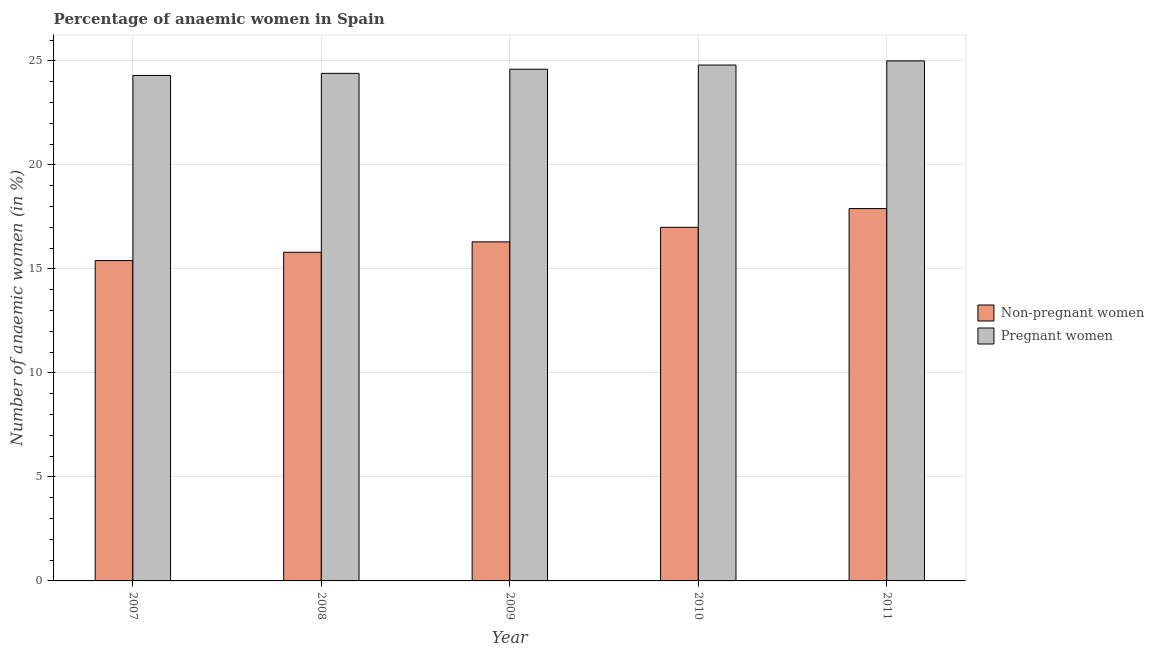How many different coloured bars are there?
Provide a short and direct response. 2. Are the number of bars per tick equal to the number of legend labels?
Ensure brevity in your answer.  Yes. Are the number of bars on each tick of the X-axis equal?
Keep it short and to the point. Yes. How many bars are there on the 2nd tick from the left?
Your answer should be very brief. 2. In how many cases, is the number of bars for a given year not equal to the number of legend labels?
Keep it short and to the point. 0. What is the percentage of non-pregnant anaemic women in 2008?
Make the answer very short. 15.8. Across all years, what is the maximum percentage of pregnant anaemic women?
Give a very brief answer. 25. In which year was the percentage of non-pregnant anaemic women minimum?
Your answer should be compact. 2007. What is the total percentage of pregnant anaemic women in the graph?
Provide a short and direct response. 123.1. What is the difference between the percentage of pregnant anaemic women in 2009 and that in 2011?
Keep it short and to the point. -0.4. What is the difference between the percentage of pregnant anaemic women in 2010 and the percentage of non-pregnant anaemic women in 2007?
Keep it short and to the point. 0.5. What is the average percentage of non-pregnant anaemic women per year?
Keep it short and to the point. 16.48. What is the ratio of the percentage of non-pregnant anaemic women in 2007 to that in 2010?
Provide a succinct answer. 0.91. What is the difference between the highest and the second highest percentage of pregnant anaemic women?
Your response must be concise. 0.2. What is the difference between the highest and the lowest percentage of non-pregnant anaemic women?
Your answer should be very brief. 2.5. Is the sum of the percentage of pregnant anaemic women in 2007 and 2011 greater than the maximum percentage of non-pregnant anaemic women across all years?
Ensure brevity in your answer.  Yes. What does the 1st bar from the left in 2011 represents?
Your answer should be compact. Non-pregnant women. What does the 1st bar from the right in 2011 represents?
Provide a short and direct response. Pregnant women. How many bars are there?
Give a very brief answer. 10. How many years are there in the graph?
Provide a succinct answer. 5. Where does the legend appear in the graph?
Provide a succinct answer. Center right. How many legend labels are there?
Your response must be concise. 2. What is the title of the graph?
Provide a short and direct response. Percentage of anaemic women in Spain. What is the label or title of the Y-axis?
Ensure brevity in your answer.  Number of anaemic women (in %). What is the Number of anaemic women (in %) in Pregnant women in 2007?
Offer a terse response. 24.3. What is the Number of anaemic women (in %) of Pregnant women in 2008?
Keep it short and to the point. 24.4. What is the Number of anaemic women (in %) of Non-pregnant women in 2009?
Offer a very short reply. 16.3. What is the Number of anaemic women (in %) in Pregnant women in 2009?
Your response must be concise. 24.6. What is the Number of anaemic women (in %) of Pregnant women in 2010?
Your answer should be compact. 24.8. What is the Number of anaemic women (in %) in Pregnant women in 2011?
Your answer should be very brief. 25. Across all years, what is the minimum Number of anaemic women (in %) in Non-pregnant women?
Your answer should be compact. 15.4. Across all years, what is the minimum Number of anaemic women (in %) of Pregnant women?
Your answer should be compact. 24.3. What is the total Number of anaemic women (in %) of Non-pregnant women in the graph?
Your answer should be compact. 82.4. What is the total Number of anaemic women (in %) of Pregnant women in the graph?
Give a very brief answer. 123.1. What is the difference between the Number of anaemic women (in %) of Non-pregnant women in 2007 and that in 2008?
Offer a very short reply. -0.4. What is the difference between the Number of anaemic women (in %) in Pregnant women in 2007 and that in 2008?
Provide a succinct answer. -0.1. What is the difference between the Number of anaemic women (in %) in Non-pregnant women in 2007 and that in 2010?
Make the answer very short. -1.6. What is the difference between the Number of anaemic women (in %) of Pregnant women in 2007 and that in 2010?
Offer a very short reply. -0.5. What is the difference between the Number of anaemic women (in %) in Pregnant women in 2007 and that in 2011?
Your answer should be compact. -0.7. What is the difference between the Number of anaemic women (in %) of Non-pregnant women in 2008 and that in 2009?
Your response must be concise. -0.5. What is the difference between the Number of anaemic women (in %) of Pregnant women in 2008 and that in 2009?
Keep it short and to the point. -0.2. What is the difference between the Number of anaemic women (in %) in Non-pregnant women in 2008 and that in 2010?
Give a very brief answer. -1.2. What is the difference between the Number of anaemic women (in %) of Pregnant women in 2008 and that in 2010?
Your response must be concise. -0.4. What is the difference between the Number of anaemic women (in %) of Non-pregnant women in 2008 and that in 2011?
Offer a terse response. -2.1. What is the difference between the Number of anaemic women (in %) in Pregnant women in 2009 and that in 2010?
Ensure brevity in your answer.  -0.2. What is the difference between the Number of anaemic women (in %) of Pregnant women in 2010 and that in 2011?
Your answer should be very brief. -0.2. What is the difference between the Number of anaemic women (in %) of Non-pregnant women in 2007 and the Number of anaemic women (in %) of Pregnant women in 2009?
Provide a succinct answer. -9.2. What is the difference between the Number of anaemic women (in %) in Non-pregnant women in 2007 and the Number of anaemic women (in %) in Pregnant women in 2010?
Your response must be concise. -9.4. What is the difference between the Number of anaemic women (in %) of Non-pregnant women in 2008 and the Number of anaemic women (in %) of Pregnant women in 2009?
Provide a short and direct response. -8.8. What is the difference between the Number of anaemic women (in %) of Non-pregnant women in 2008 and the Number of anaemic women (in %) of Pregnant women in 2010?
Your answer should be very brief. -9. What is the difference between the Number of anaemic women (in %) in Non-pregnant women in 2009 and the Number of anaemic women (in %) in Pregnant women in 2010?
Your answer should be very brief. -8.5. What is the difference between the Number of anaemic women (in %) of Non-pregnant women in 2010 and the Number of anaemic women (in %) of Pregnant women in 2011?
Give a very brief answer. -8. What is the average Number of anaemic women (in %) of Non-pregnant women per year?
Your answer should be very brief. 16.48. What is the average Number of anaemic women (in %) of Pregnant women per year?
Provide a short and direct response. 24.62. In the year 2011, what is the difference between the Number of anaemic women (in %) in Non-pregnant women and Number of anaemic women (in %) in Pregnant women?
Provide a succinct answer. -7.1. What is the ratio of the Number of anaemic women (in %) in Non-pregnant women in 2007 to that in 2008?
Provide a succinct answer. 0.97. What is the ratio of the Number of anaemic women (in %) of Non-pregnant women in 2007 to that in 2009?
Offer a terse response. 0.94. What is the ratio of the Number of anaemic women (in %) of Non-pregnant women in 2007 to that in 2010?
Keep it short and to the point. 0.91. What is the ratio of the Number of anaemic women (in %) in Pregnant women in 2007 to that in 2010?
Keep it short and to the point. 0.98. What is the ratio of the Number of anaemic women (in %) in Non-pregnant women in 2007 to that in 2011?
Your answer should be compact. 0.86. What is the ratio of the Number of anaemic women (in %) of Pregnant women in 2007 to that in 2011?
Keep it short and to the point. 0.97. What is the ratio of the Number of anaemic women (in %) of Non-pregnant women in 2008 to that in 2009?
Offer a terse response. 0.97. What is the ratio of the Number of anaemic women (in %) of Pregnant women in 2008 to that in 2009?
Provide a succinct answer. 0.99. What is the ratio of the Number of anaemic women (in %) in Non-pregnant women in 2008 to that in 2010?
Offer a terse response. 0.93. What is the ratio of the Number of anaemic women (in %) in Pregnant women in 2008 to that in 2010?
Ensure brevity in your answer.  0.98. What is the ratio of the Number of anaemic women (in %) of Non-pregnant women in 2008 to that in 2011?
Provide a short and direct response. 0.88. What is the ratio of the Number of anaemic women (in %) of Non-pregnant women in 2009 to that in 2010?
Ensure brevity in your answer.  0.96. What is the ratio of the Number of anaemic women (in %) in Pregnant women in 2009 to that in 2010?
Provide a short and direct response. 0.99. What is the ratio of the Number of anaemic women (in %) of Non-pregnant women in 2009 to that in 2011?
Provide a succinct answer. 0.91. What is the ratio of the Number of anaemic women (in %) of Non-pregnant women in 2010 to that in 2011?
Provide a short and direct response. 0.95. What is the ratio of the Number of anaemic women (in %) of Pregnant women in 2010 to that in 2011?
Ensure brevity in your answer.  0.99. What is the difference between the highest and the second highest Number of anaemic women (in %) in Non-pregnant women?
Offer a very short reply. 0.9. What is the difference between the highest and the lowest Number of anaemic women (in %) in Non-pregnant women?
Keep it short and to the point. 2.5. What is the difference between the highest and the lowest Number of anaemic women (in %) of Pregnant women?
Your answer should be compact. 0.7. 